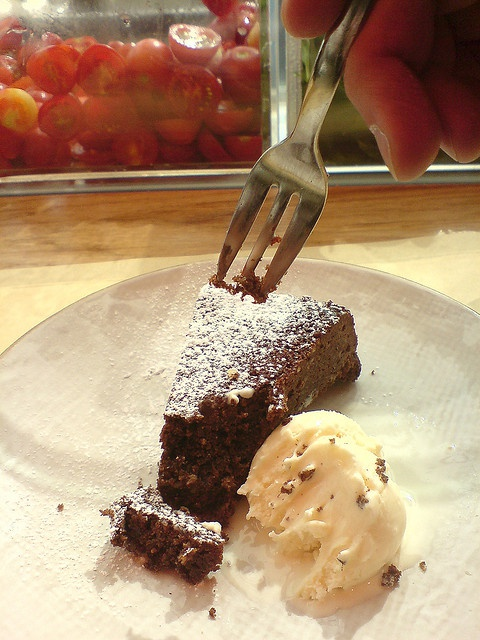Describe the objects in this image and their specific colors. I can see cake in lightyellow, black, maroon, and beige tones, people in lightyellow, maroon, black, and brown tones, cake in lightyellow, tan, and khaki tones, and fork in lightyellow, maroon, tan, and gray tones in this image. 